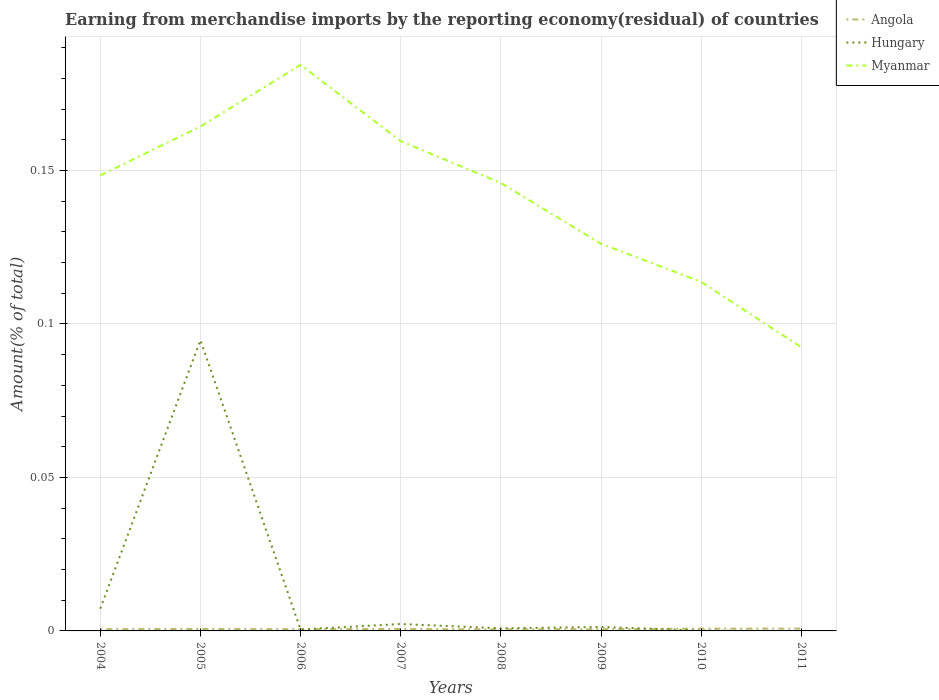Across all years, what is the maximum percentage of amount earned from merchandise imports in Myanmar?
Keep it short and to the point. 0.09. What is the total percentage of amount earned from merchandise imports in Hungary in the graph?
Offer a terse response. 0.09. What is the difference between the highest and the second highest percentage of amount earned from merchandise imports in Hungary?
Give a very brief answer. 0.09. What is the difference between two consecutive major ticks on the Y-axis?
Provide a short and direct response. 0.05. Are the values on the major ticks of Y-axis written in scientific E-notation?
Offer a very short reply. No. Does the graph contain grids?
Ensure brevity in your answer.  Yes. What is the title of the graph?
Ensure brevity in your answer.  Earning from merchandise imports by the reporting economy(residual) of countries. What is the label or title of the X-axis?
Give a very brief answer. Years. What is the label or title of the Y-axis?
Your response must be concise. Amount(% of total). What is the Amount(% of total) of Angola in 2004?
Keep it short and to the point. 0. What is the Amount(% of total) of Hungary in 2004?
Offer a very short reply. 0.01. What is the Amount(% of total) of Myanmar in 2004?
Ensure brevity in your answer.  0.15. What is the Amount(% of total) of Angola in 2005?
Make the answer very short. 0. What is the Amount(% of total) of Hungary in 2005?
Keep it short and to the point. 0.09. What is the Amount(% of total) in Myanmar in 2005?
Provide a short and direct response. 0.16. What is the Amount(% of total) of Angola in 2006?
Offer a terse response. 0. What is the Amount(% of total) in Hungary in 2006?
Provide a succinct answer. 0. What is the Amount(% of total) in Myanmar in 2006?
Your response must be concise. 0.18. What is the Amount(% of total) in Angola in 2007?
Provide a short and direct response. 0. What is the Amount(% of total) of Hungary in 2007?
Your answer should be compact. 0. What is the Amount(% of total) in Myanmar in 2007?
Keep it short and to the point. 0.16. What is the Amount(% of total) of Angola in 2008?
Your response must be concise. 0. What is the Amount(% of total) in Hungary in 2008?
Give a very brief answer. 0. What is the Amount(% of total) in Myanmar in 2008?
Give a very brief answer. 0.15. What is the Amount(% of total) in Angola in 2009?
Keep it short and to the point. 0. What is the Amount(% of total) of Hungary in 2009?
Your response must be concise. 0. What is the Amount(% of total) of Myanmar in 2009?
Keep it short and to the point. 0.13. What is the Amount(% of total) in Angola in 2010?
Provide a short and direct response. 0. What is the Amount(% of total) in Hungary in 2010?
Offer a terse response. 0. What is the Amount(% of total) in Myanmar in 2010?
Your answer should be compact. 0.11. What is the Amount(% of total) of Angola in 2011?
Make the answer very short. 0. What is the Amount(% of total) in Hungary in 2011?
Make the answer very short. 0. What is the Amount(% of total) of Myanmar in 2011?
Offer a very short reply. 0.09. Across all years, what is the maximum Amount(% of total) of Angola?
Ensure brevity in your answer.  0. Across all years, what is the maximum Amount(% of total) in Hungary?
Provide a succinct answer. 0.09. Across all years, what is the maximum Amount(% of total) of Myanmar?
Make the answer very short. 0.18. Across all years, what is the minimum Amount(% of total) of Angola?
Make the answer very short. 0. Across all years, what is the minimum Amount(% of total) of Myanmar?
Your answer should be compact. 0.09. What is the total Amount(% of total) of Angola in the graph?
Offer a very short reply. 0.01. What is the total Amount(% of total) in Hungary in the graph?
Your answer should be very brief. 0.11. What is the total Amount(% of total) in Myanmar in the graph?
Ensure brevity in your answer.  1.13. What is the difference between the Amount(% of total) in Angola in 2004 and that in 2005?
Your answer should be very brief. -0. What is the difference between the Amount(% of total) in Hungary in 2004 and that in 2005?
Your response must be concise. -0.09. What is the difference between the Amount(% of total) in Myanmar in 2004 and that in 2005?
Give a very brief answer. -0.02. What is the difference between the Amount(% of total) of Hungary in 2004 and that in 2006?
Provide a short and direct response. 0.01. What is the difference between the Amount(% of total) in Myanmar in 2004 and that in 2006?
Keep it short and to the point. -0.04. What is the difference between the Amount(% of total) of Angola in 2004 and that in 2007?
Keep it short and to the point. -0. What is the difference between the Amount(% of total) of Hungary in 2004 and that in 2007?
Your answer should be compact. 0.01. What is the difference between the Amount(% of total) in Myanmar in 2004 and that in 2007?
Offer a terse response. -0.01. What is the difference between the Amount(% of total) in Angola in 2004 and that in 2008?
Your answer should be compact. 0. What is the difference between the Amount(% of total) of Hungary in 2004 and that in 2008?
Make the answer very short. 0.01. What is the difference between the Amount(% of total) in Myanmar in 2004 and that in 2008?
Ensure brevity in your answer.  0. What is the difference between the Amount(% of total) of Hungary in 2004 and that in 2009?
Make the answer very short. 0.01. What is the difference between the Amount(% of total) in Myanmar in 2004 and that in 2009?
Provide a short and direct response. 0.02. What is the difference between the Amount(% of total) in Angola in 2004 and that in 2010?
Offer a terse response. -0. What is the difference between the Amount(% of total) of Hungary in 2004 and that in 2010?
Give a very brief answer. 0.01. What is the difference between the Amount(% of total) in Myanmar in 2004 and that in 2010?
Provide a succinct answer. 0.03. What is the difference between the Amount(% of total) of Angola in 2004 and that in 2011?
Offer a very short reply. -0. What is the difference between the Amount(% of total) in Myanmar in 2004 and that in 2011?
Give a very brief answer. 0.06. What is the difference between the Amount(% of total) of Angola in 2005 and that in 2006?
Your response must be concise. 0. What is the difference between the Amount(% of total) of Hungary in 2005 and that in 2006?
Offer a very short reply. 0.09. What is the difference between the Amount(% of total) in Myanmar in 2005 and that in 2006?
Your response must be concise. -0.02. What is the difference between the Amount(% of total) in Angola in 2005 and that in 2007?
Give a very brief answer. -0. What is the difference between the Amount(% of total) in Hungary in 2005 and that in 2007?
Provide a succinct answer. 0.09. What is the difference between the Amount(% of total) of Myanmar in 2005 and that in 2007?
Your response must be concise. 0. What is the difference between the Amount(% of total) of Hungary in 2005 and that in 2008?
Give a very brief answer. 0.09. What is the difference between the Amount(% of total) of Myanmar in 2005 and that in 2008?
Give a very brief answer. 0.02. What is the difference between the Amount(% of total) of Angola in 2005 and that in 2009?
Give a very brief answer. 0. What is the difference between the Amount(% of total) in Hungary in 2005 and that in 2009?
Keep it short and to the point. 0.09. What is the difference between the Amount(% of total) of Myanmar in 2005 and that in 2009?
Provide a succinct answer. 0.04. What is the difference between the Amount(% of total) of Angola in 2005 and that in 2010?
Ensure brevity in your answer.  -0. What is the difference between the Amount(% of total) in Hungary in 2005 and that in 2010?
Provide a short and direct response. 0.09. What is the difference between the Amount(% of total) in Myanmar in 2005 and that in 2010?
Your answer should be very brief. 0.05. What is the difference between the Amount(% of total) of Angola in 2005 and that in 2011?
Offer a very short reply. -0. What is the difference between the Amount(% of total) in Myanmar in 2005 and that in 2011?
Your answer should be compact. 0.07. What is the difference between the Amount(% of total) of Angola in 2006 and that in 2007?
Your answer should be compact. -0. What is the difference between the Amount(% of total) in Hungary in 2006 and that in 2007?
Your response must be concise. -0. What is the difference between the Amount(% of total) in Myanmar in 2006 and that in 2007?
Your answer should be compact. 0.02. What is the difference between the Amount(% of total) of Hungary in 2006 and that in 2008?
Offer a very short reply. -0. What is the difference between the Amount(% of total) of Myanmar in 2006 and that in 2008?
Your answer should be very brief. 0.04. What is the difference between the Amount(% of total) of Angola in 2006 and that in 2009?
Your answer should be very brief. 0. What is the difference between the Amount(% of total) of Hungary in 2006 and that in 2009?
Ensure brevity in your answer.  -0. What is the difference between the Amount(% of total) of Myanmar in 2006 and that in 2009?
Give a very brief answer. 0.06. What is the difference between the Amount(% of total) in Angola in 2006 and that in 2010?
Your answer should be very brief. -0. What is the difference between the Amount(% of total) in Myanmar in 2006 and that in 2010?
Provide a succinct answer. 0.07. What is the difference between the Amount(% of total) of Angola in 2006 and that in 2011?
Provide a short and direct response. -0. What is the difference between the Amount(% of total) of Myanmar in 2006 and that in 2011?
Offer a very short reply. 0.09. What is the difference between the Amount(% of total) of Angola in 2007 and that in 2008?
Your answer should be compact. 0. What is the difference between the Amount(% of total) in Hungary in 2007 and that in 2008?
Make the answer very short. 0. What is the difference between the Amount(% of total) in Myanmar in 2007 and that in 2008?
Give a very brief answer. 0.01. What is the difference between the Amount(% of total) of Hungary in 2007 and that in 2009?
Give a very brief answer. 0. What is the difference between the Amount(% of total) of Myanmar in 2007 and that in 2009?
Provide a short and direct response. 0.03. What is the difference between the Amount(% of total) in Angola in 2007 and that in 2010?
Make the answer very short. -0. What is the difference between the Amount(% of total) in Hungary in 2007 and that in 2010?
Your answer should be very brief. 0. What is the difference between the Amount(% of total) in Myanmar in 2007 and that in 2010?
Your answer should be compact. 0.05. What is the difference between the Amount(% of total) in Angola in 2007 and that in 2011?
Your response must be concise. -0. What is the difference between the Amount(% of total) in Myanmar in 2007 and that in 2011?
Your response must be concise. 0.07. What is the difference between the Amount(% of total) of Angola in 2008 and that in 2009?
Provide a succinct answer. -0. What is the difference between the Amount(% of total) in Hungary in 2008 and that in 2009?
Your answer should be compact. -0. What is the difference between the Amount(% of total) of Myanmar in 2008 and that in 2009?
Your response must be concise. 0.02. What is the difference between the Amount(% of total) in Angola in 2008 and that in 2010?
Offer a very short reply. -0. What is the difference between the Amount(% of total) in Hungary in 2008 and that in 2010?
Give a very brief answer. 0. What is the difference between the Amount(% of total) of Myanmar in 2008 and that in 2010?
Ensure brevity in your answer.  0.03. What is the difference between the Amount(% of total) of Angola in 2008 and that in 2011?
Ensure brevity in your answer.  -0. What is the difference between the Amount(% of total) of Myanmar in 2008 and that in 2011?
Ensure brevity in your answer.  0.05. What is the difference between the Amount(% of total) in Angola in 2009 and that in 2010?
Your response must be concise. -0. What is the difference between the Amount(% of total) in Hungary in 2009 and that in 2010?
Give a very brief answer. 0. What is the difference between the Amount(% of total) in Myanmar in 2009 and that in 2010?
Your answer should be very brief. 0.01. What is the difference between the Amount(% of total) of Angola in 2009 and that in 2011?
Your answer should be very brief. -0. What is the difference between the Amount(% of total) of Myanmar in 2009 and that in 2011?
Make the answer very short. 0.03. What is the difference between the Amount(% of total) of Angola in 2010 and that in 2011?
Offer a terse response. -0. What is the difference between the Amount(% of total) in Myanmar in 2010 and that in 2011?
Your answer should be very brief. 0.02. What is the difference between the Amount(% of total) of Angola in 2004 and the Amount(% of total) of Hungary in 2005?
Give a very brief answer. -0.09. What is the difference between the Amount(% of total) in Angola in 2004 and the Amount(% of total) in Myanmar in 2005?
Your response must be concise. -0.16. What is the difference between the Amount(% of total) of Hungary in 2004 and the Amount(% of total) of Myanmar in 2005?
Provide a succinct answer. -0.16. What is the difference between the Amount(% of total) of Angola in 2004 and the Amount(% of total) of Hungary in 2006?
Your answer should be very brief. 0. What is the difference between the Amount(% of total) of Angola in 2004 and the Amount(% of total) of Myanmar in 2006?
Your response must be concise. -0.18. What is the difference between the Amount(% of total) in Hungary in 2004 and the Amount(% of total) in Myanmar in 2006?
Your response must be concise. -0.18. What is the difference between the Amount(% of total) of Angola in 2004 and the Amount(% of total) of Hungary in 2007?
Keep it short and to the point. -0. What is the difference between the Amount(% of total) of Angola in 2004 and the Amount(% of total) of Myanmar in 2007?
Make the answer very short. -0.16. What is the difference between the Amount(% of total) in Hungary in 2004 and the Amount(% of total) in Myanmar in 2007?
Your response must be concise. -0.15. What is the difference between the Amount(% of total) of Angola in 2004 and the Amount(% of total) of Hungary in 2008?
Keep it short and to the point. -0. What is the difference between the Amount(% of total) in Angola in 2004 and the Amount(% of total) in Myanmar in 2008?
Provide a short and direct response. -0.15. What is the difference between the Amount(% of total) in Hungary in 2004 and the Amount(% of total) in Myanmar in 2008?
Give a very brief answer. -0.14. What is the difference between the Amount(% of total) of Angola in 2004 and the Amount(% of total) of Hungary in 2009?
Give a very brief answer. -0. What is the difference between the Amount(% of total) in Angola in 2004 and the Amount(% of total) in Myanmar in 2009?
Make the answer very short. -0.13. What is the difference between the Amount(% of total) of Hungary in 2004 and the Amount(% of total) of Myanmar in 2009?
Your answer should be compact. -0.12. What is the difference between the Amount(% of total) of Angola in 2004 and the Amount(% of total) of Hungary in 2010?
Provide a succinct answer. 0. What is the difference between the Amount(% of total) in Angola in 2004 and the Amount(% of total) in Myanmar in 2010?
Provide a succinct answer. -0.11. What is the difference between the Amount(% of total) of Hungary in 2004 and the Amount(% of total) of Myanmar in 2010?
Offer a very short reply. -0.11. What is the difference between the Amount(% of total) of Angola in 2004 and the Amount(% of total) of Myanmar in 2011?
Offer a terse response. -0.09. What is the difference between the Amount(% of total) of Hungary in 2004 and the Amount(% of total) of Myanmar in 2011?
Offer a terse response. -0.09. What is the difference between the Amount(% of total) in Angola in 2005 and the Amount(% of total) in Myanmar in 2006?
Ensure brevity in your answer.  -0.18. What is the difference between the Amount(% of total) in Hungary in 2005 and the Amount(% of total) in Myanmar in 2006?
Your answer should be very brief. -0.09. What is the difference between the Amount(% of total) in Angola in 2005 and the Amount(% of total) in Hungary in 2007?
Keep it short and to the point. -0. What is the difference between the Amount(% of total) of Angola in 2005 and the Amount(% of total) of Myanmar in 2007?
Give a very brief answer. -0.16. What is the difference between the Amount(% of total) in Hungary in 2005 and the Amount(% of total) in Myanmar in 2007?
Your response must be concise. -0.06. What is the difference between the Amount(% of total) in Angola in 2005 and the Amount(% of total) in Hungary in 2008?
Your response must be concise. -0. What is the difference between the Amount(% of total) of Angola in 2005 and the Amount(% of total) of Myanmar in 2008?
Provide a succinct answer. -0.15. What is the difference between the Amount(% of total) in Hungary in 2005 and the Amount(% of total) in Myanmar in 2008?
Provide a short and direct response. -0.05. What is the difference between the Amount(% of total) in Angola in 2005 and the Amount(% of total) in Hungary in 2009?
Provide a short and direct response. -0. What is the difference between the Amount(% of total) of Angola in 2005 and the Amount(% of total) of Myanmar in 2009?
Provide a succinct answer. -0.13. What is the difference between the Amount(% of total) of Hungary in 2005 and the Amount(% of total) of Myanmar in 2009?
Make the answer very short. -0.03. What is the difference between the Amount(% of total) in Angola in 2005 and the Amount(% of total) in Hungary in 2010?
Your answer should be compact. 0. What is the difference between the Amount(% of total) of Angola in 2005 and the Amount(% of total) of Myanmar in 2010?
Give a very brief answer. -0.11. What is the difference between the Amount(% of total) in Hungary in 2005 and the Amount(% of total) in Myanmar in 2010?
Give a very brief answer. -0.02. What is the difference between the Amount(% of total) in Angola in 2005 and the Amount(% of total) in Myanmar in 2011?
Make the answer very short. -0.09. What is the difference between the Amount(% of total) of Hungary in 2005 and the Amount(% of total) of Myanmar in 2011?
Make the answer very short. 0. What is the difference between the Amount(% of total) in Angola in 2006 and the Amount(% of total) in Hungary in 2007?
Offer a terse response. -0. What is the difference between the Amount(% of total) in Angola in 2006 and the Amount(% of total) in Myanmar in 2007?
Your answer should be compact. -0.16. What is the difference between the Amount(% of total) in Hungary in 2006 and the Amount(% of total) in Myanmar in 2007?
Your answer should be compact. -0.16. What is the difference between the Amount(% of total) in Angola in 2006 and the Amount(% of total) in Hungary in 2008?
Your response must be concise. -0. What is the difference between the Amount(% of total) of Angola in 2006 and the Amount(% of total) of Myanmar in 2008?
Your answer should be compact. -0.15. What is the difference between the Amount(% of total) of Hungary in 2006 and the Amount(% of total) of Myanmar in 2008?
Offer a very short reply. -0.15. What is the difference between the Amount(% of total) in Angola in 2006 and the Amount(% of total) in Hungary in 2009?
Your answer should be very brief. -0. What is the difference between the Amount(% of total) in Angola in 2006 and the Amount(% of total) in Myanmar in 2009?
Give a very brief answer. -0.13. What is the difference between the Amount(% of total) of Hungary in 2006 and the Amount(% of total) of Myanmar in 2009?
Your answer should be compact. -0.13. What is the difference between the Amount(% of total) of Angola in 2006 and the Amount(% of total) of Hungary in 2010?
Your answer should be compact. 0. What is the difference between the Amount(% of total) in Angola in 2006 and the Amount(% of total) in Myanmar in 2010?
Make the answer very short. -0.11. What is the difference between the Amount(% of total) of Hungary in 2006 and the Amount(% of total) of Myanmar in 2010?
Offer a very short reply. -0.11. What is the difference between the Amount(% of total) in Angola in 2006 and the Amount(% of total) in Myanmar in 2011?
Provide a short and direct response. -0.09. What is the difference between the Amount(% of total) of Hungary in 2006 and the Amount(% of total) of Myanmar in 2011?
Your answer should be very brief. -0.09. What is the difference between the Amount(% of total) of Angola in 2007 and the Amount(% of total) of Hungary in 2008?
Make the answer very short. -0. What is the difference between the Amount(% of total) of Angola in 2007 and the Amount(% of total) of Myanmar in 2008?
Offer a terse response. -0.15. What is the difference between the Amount(% of total) of Hungary in 2007 and the Amount(% of total) of Myanmar in 2008?
Your answer should be compact. -0.14. What is the difference between the Amount(% of total) in Angola in 2007 and the Amount(% of total) in Hungary in 2009?
Offer a very short reply. -0. What is the difference between the Amount(% of total) of Angola in 2007 and the Amount(% of total) of Myanmar in 2009?
Keep it short and to the point. -0.13. What is the difference between the Amount(% of total) in Hungary in 2007 and the Amount(% of total) in Myanmar in 2009?
Make the answer very short. -0.12. What is the difference between the Amount(% of total) in Angola in 2007 and the Amount(% of total) in Myanmar in 2010?
Provide a succinct answer. -0.11. What is the difference between the Amount(% of total) of Hungary in 2007 and the Amount(% of total) of Myanmar in 2010?
Your response must be concise. -0.11. What is the difference between the Amount(% of total) of Angola in 2007 and the Amount(% of total) of Myanmar in 2011?
Your answer should be very brief. -0.09. What is the difference between the Amount(% of total) in Hungary in 2007 and the Amount(% of total) in Myanmar in 2011?
Offer a terse response. -0.09. What is the difference between the Amount(% of total) in Angola in 2008 and the Amount(% of total) in Hungary in 2009?
Provide a succinct answer. -0. What is the difference between the Amount(% of total) in Angola in 2008 and the Amount(% of total) in Myanmar in 2009?
Your answer should be very brief. -0.13. What is the difference between the Amount(% of total) in Hungary in 2008 and the Amount(% of total) in Myanmar in 2009?
Make the answer very short. -0.13. What is the difference between the Amount(% of total) of Angola in 2008 and the Amount(% of total) of Myanmar in 2010?
Offer a very short reply. -0.11. What is the difference between the Amount(% of total) of Hungary in 2008 and the Amount(% of total) of Myanmar in 2010?
Give a very brief answer. -0.11. What is the difference between the Amount(% of total) in Angola in 2008 and the Amount(% of total) in Myanmar in 2011?
Your answer should be very brief. -0.09. What is the difference between the Amount(% of total) of Hungary in 2008 and the Amount(% of total) of Myanmar in 2011?
Your response must be concise. -0.09. What is the difference between the Amount(% of total) in Angola in 2009 and the Amount(% of total) in Hungary in 2010?
Your answer should be compact. 0. What is the difference between the Amount(% of total) of Angola in 2009 and the Amount(% of total) of Myanmar in 2010?
Your answer should be compact. -0.11. What is the difference between the Amount(% of total) in Hungary in 2009 and the Amount(% of total) in Myanmar in 2010?
Give a very brief answer. -0.11. What is the difference between the Amount(% of total) of Angola in 2009 and the Amount(% of total) of Myanmar in 2011?
Provide a short and direct response. -0.09. What is the difference between the Amount(% of total) in Hungary in 2009 and the Amount(% of total) in Myanmar in 2011?
Offer a very short reply. -0.09. What is the difference between the Amount(% of total) of Angola in 2010 and the Amount(% of total) of Myanmar in 2011?
Provide a succinct answer. -0.09. What is the difference between the Amount(% of total) of Hungary in 2010 and the Amount(% of total) of Myanmar in 2011?
Ensure brevity in your answer.  -0.09. What is the average Amount(% of total) of Angola per year?
Make the answer very short. 0. What is the average Amount(% of total) in Hungary per year?
Ensure brevity in your answer.  0.01. What is the average Amount(% of total) in Myanmar per year?
Offer a terse response. 0.14. In the year 2004, what is the difference between the Amount(% of total) in Angola and Amount(% of total) in Hungary?
Provide a succinct answer. -0.01. In the year 2004, what is the difference between the Amount(% of total) of Angola and Amount(% of total) of Myanmar?
Make the answer very short. -0.15. In the year 2004, what is the difference between the Amount(% of total) of Hungary and Amount(% of total) of Myanmar?
Your response must be concise. -0.14. In the year 2005, what is the difference between the Amount(% of total) in Angola and Amount(% of total) in Hungary?
Provide a short and direct response. -0.09. In the year 2005, what is the difference between the Amount(% of total) in Angola and Amount(% of total) in Myanmar?
Make the answer very short. -0.16. In the year 2005, what is the difference between the Amount(% of total) in Hungary and Amount(% of total) in Myanmar?
Make the answer very short. -0.07. In the year 2006, what is the difference between the Amount(% of total) of Angola and Amount(% of total) of Hungary?
Make the answer very short. 0. In the year 2006, what is the difference between the Amount(% of total) in Angola and Amount(% of total) in Myanmar?
Provide a succinct answer. -0.18. In the year 2006, what is the difference between the Amount(% of total) in Hungary and Amount(% of total) in Myanmar?
Offer a very short reply. -0.18. In the year 2007, what is the difference between the Amount(% of total) in Angola and Amount(% of total) in Hungary?
Offer a terse response. -0. In the year 2007, what is the difference between the Amount(% of total) of Angola and Amount(% of total) of Myanmar?
Give a very brief answer. -0.16. In the year 2007, what is the difference between the Amount(% of total) in Hungary and Amount(% of total) in Myanmar?
Offer a terse response. -0.16. In the year 2008, what is the difference between the Amount(% of total) in Angola and Amount(% of total) in Hungary?
Make the answer very short. -0. In the year 2008, what is the difference between the Amount(% of total) in Angola and Amount(% of total) in Myanmar?
Your answer should be very brief. -0.15. In the year 2008, what is the difference between the Amount(% of total) of Hungary and Amount(% of total) of Myanmar?
Provide a succinct answer. -0.15. In the year 2009, what is the difference between the Amount(% of total) in Angola and Amount(% of total) in Hungary?
Provide a short and direct response. -0. In the year 2009, what is the difference between the Amount(% of total) of Angola and Amount(% of total) of Myanmar?
Make the answer very short. -0.13. In the year 2009, what is the difference between the Amount(% of total) in Hungary and Amount(% of total) in Myanmar?
Provide a succinct answer. -0.12. In the year 2010, what is the difference between the Amount(% of total) in Angola and Amount(% of total) in Hungary?
Make the answer very short. 0. In the year 2010, what is the difference between the Amount(% of total) of Angola and Amount(% of total) of Myanmar?
Your answer should be very brief. -0.11. In the year 2010, what is the difference between the Amount(% of total) in Hungary and Amount(% of total) in Myanmar?
Your answer should be compact. -0.11. In the year 2011, what is the difference between the Amount(% of total) in Angola and Amount(% of total) in Myanmar?
Your response must be concise. -0.09. What is the ratio of the Amount(% of total) of Angola in 2004 to that in 2005?
Give a very brief answer. 0.92. What is the ratio of the Amount(% of total) in Hungary in 2004 to that in 2005?
Keep it short and to the point. 0.08. What is the ratio of the Amount(% of total) in Myanmar in 2004 to that in 2005?
Provide a succinct answer. 0.9. What is the ratio of the Amount(% of total) of Angola in 2004 to that in 2006?
Offer a terse response. 1.02. What is the ratio of the Amount(% of total) in Hungary in 2004 to that in 2006?
Your answer should be very brief. 15.88. What is the ratio of the Amount(% of total) in Myanmar in 2004 to that in 2006?
Your answer should be compact. 0.8. What is the ratio of the Amount(% of total) of Angola in 2004 to that in 2007?
Your response must be concise. 0.91. What is the ratio of the Amount(% of total) in Hungary in 2004 to that in 2007?
Offer a terse response. 3.22. What is the ratio of the Amount(% of total) of Myanmar in 2004 to that in 2007?
Ensure brevity in your answer.  0.93. What is the ratio of the Amount(% of total) in Angola in 2004 to that in 2008?
Provide a succinct answer. 1.19. What is the ratio of the Amount(% of total) of Hungary in 2004 to that in 2008?
Make the answer very short. 8.52. What is the ratio of the Amount(% of total) of Myanmar in 2004 to that in 2008?
Your answer should be compact. 1.02. What is the ratio of the Amount(% of total) in Angola in 2004 to that in 2009?
Ensure brevity in your answer.  1.03. What is the ratio of the Amount(% of total) in Hungary in 2004 to that in 2009?
Provide a succinct answer. 5.64. What is the ratio of the Amount(% of total) in Myanmar in 2004 to that in 2009?
Offer a terse response. 1.18. What is the ratio of the Amount(% of total) in Angola in 2004 to that in 2010?
Ensure brevity in your answer.  0.78. What is the ratio of the Amount(% of total) of Hungary in 2004 to that in 2010?
Provide a short and direct response. 55.19. What is the ratio of the Amount(% of total) of Myanmar in 2004 to that in 2010?
Give a very brief answer. 1.3. What is the ratio of the Amount(% of total) of Angola in 2004 to that in 2011?
Keep it short and to the point. 0.77. What is the ratio of the Amount(% of total) in Myanmar in 2004 to that in 2011?
Provide a short and direct response. 1.61. What is the ratio of the Amount(% of total) of Angola in 2005 to that in 2006?
Offer a very short reply. 1.11. What is the ratio of the Amount(% of total) of Hungary in 2005 to that in 2006?
Provide a short and direct response. 207.14. What is the ratio of the Amount(% of total) of Myanmar in 2005 to that in 2006?
Make the answer very short. 0.89. What is the ratio of the Amount(% of total) in Angola in 2005 to that in 2007?
Provide a short and direct response. 1. What is the ratio of the Amount(% of total) in Hungary in 2005 to that in 2007?
Offer a very short reply. 42.05. What is the ratio of the Amount(% of total) of Myanmar in 2005 to that in 2007?
Offer a terse response. 1.03. What is the ratio of the Amount(% of total) in Angola in 2005 to that in 2008?
Give a very brief answer. 1.29. What is the ratio of the Amount(% of total) of Hungary in 2005 to that in 2008?
Give a very brief answer. 111.08. What is the ratio of the Amount(% of total) of Myanmar in 2005 to that in 2008?
Offer a very short reply. 1.13. What is the ratio of the Amount(% of total) in Angola in 2005 to that in 2009?
Provide a short and direct response. 1.12. What is the ratio of the Amount(% of total) of Hungary in 2005 to that in 2009?
Keep it short and to the point. 73.55. What is the ratio of the Amount(% of total) in Myanmar in 2005 to that in 2009?
Make the answer very short. 1.3. What is the ratio of the Amount(% of total) in Angola in 2005 to that in 2010?
Offer a terse response. 0.85. What is the ratio of the Amount(% of total) in Hungary in 2005 to that in 2010?
Offer a terse response. 719.96. What is the ratio of the Amount(% of total) of Myanmar in 2005 to that in 2010?
Provide a short and direct response. 1.44. What is the ratio of the Amount(% of total) in Angola in 2005 to that in 2011?
Ensure brevity in your answer.  0.84. What is the ratio of the Amount(% of total) of Myanmar in 2005 to that in 2011?
Keep it short and to the point. 1.78. What is the ratio of the Amount(% of total) in Angola in 2006 to that in 2007?
Your answer should be compact. 0.9. What is the ratio of the Amount(% of total) in Hungary in 2006 to that in 2007?
Provide a succinct answer. 0.2. What is the ratio of the Amount(% of total) of Myanmar in 2006 to that in 2007?
Your response must be concise. 1.16. What is the ratio of the Amount(% of total) of Angola in 2006 to that in 2008?
Provide a short and direct response. 1.16. What is the ratio of the Amount(% of total) of Hungary in 2006 to that in 2008?
Offer a terse response. 0.54. What is the ratio of the Amount(% of total) of Myanmar in 2006 to that in 2008?
Your answer should be very brief. 1.26. What is the ratio of the Amount(% of total) in Angola in 2006 to that in 2009?
Ensure brevity in your answer.  1.01. What is the ratio of the Amount(% of total) of Hungary in 2006 to that in 2009?
Your answer should be compact. 0.36. What is the ratio of the Amount(% of total) of Myanmar in 2006 to that in 2009?
Ensure brevity in your answer.  1.46. What is the ratio of the Amount(% of total) in Angola in 2006 to that in 2010?
Keep it short and to the point. 0.76. What is the ratio of the Amount(% of total) of Hungary in 2006 to that in 2010?
Provide a short and direct response. 3.48. What is the ratio of the Amount(% of total) in Myanmar in 2006 to that in 2010?
Your response must be concise. 1.62. What is the ratio of the Amount(% of total) in Angola in 2006 to that in 2011?
Your response must be concise. 0.75. What is the ratio of the Amount(% of total) in Myanmar in 2006 to that in 2011?
Keep it short and to the point. 2. What is the ratio of the Amount(% of total) in Angola in 2007 to that in 2008?
Offer a terse response. 1.3. What is the ratio of the Amount(% of total) in Hungary in 2007 to that in 2008?
Make the answer very short. 2.64. What is the ratio of the Amount(% of total) in Myanmar in 2007 to that in 2008?
Your answer should be very brief. 1.09. What is the ratio of the Amount(% of total) in Angola in 2007 to that in 2009?
Ensure brevity in your answer.  1.13. What is the ratio of the Amount(% of total) in Hungary in 2007 to that in 2009?
Ensure brevity in your answer.  1.75. What is the ratio of the Amount(% of total) of Myanmar in 2007 to that in 2009?
Your answer should be very brief. 1.27. What is the ratio of the Amount(% of total) of Angola in 2007 to that in 2010?
Ensure brevity in your answer.  0.85. What is the ratio of the Amount(% of total) in Hungary in 2007 to that in 2010?
Provide a short and direct response. 17.12. What is the ratio of the Amount(% of total) in Myanmar in 2007 to that in 2010?
Give a very brief answer. 1.4. What is the ratio of the Amount(% of total) of Angola in 2007 to that in 2011?
Your answer should be compact. 0.84. What is the ratio of the Amount(% of total) of Myanmar in 2007 to that in 2011?
Ensure brevity in your answer.  1.73. What is the ratio of the Amount(% of total) in Angola in 2008 to that in 2009?
Ensure brevity in your answer.  0.87. What is the ratio of the Amount(% of total) of Hungary in 2008 to that in 2009?
Your answer should be compact. 0.66. What is the ratio of the Amount(% of total) in Myanmar in 2008 to that in 2009?
Offer a terse response. 1.16. What is the ratio of the Amount(% of total) in Angola in 2008 to that in 2010?
Offer a very short reply. 0.66. What is the ratio of the Amount(% of total) in Hungary in 2008 to that in 2010?
Keep it short and to the point. 6.48. What is the ratio of the Amount(% of total) of Myanmar in 2008 to that in 2010?
Your answer should be compact. 1.28. What is the ratio of the Amount(% of total) in Angola in 2008 to that in 2011?
Your answer should be compact. 0.65. What is the ratio of the Amount(% of total) of Myanmar in 2008 to that in 2011?
Give a very brief answer. 1.58. What is the ratio of the Amount(% of total) of Angola in 2009 to that in 2010?
Offer a very short reply. 0.76. What is the ratio of the Amount(% of total) of Hungary in 2009 to that in 2010?
Offer a very short reply. 9.79. What is the ratio of the Amount(% of total) in Myanmar in 2009 to that in 2010?
Make the answer very short. 1.11. What is the ratio of the Amount(% of total) of Angola in 2009 to that in 2011?
Your response must be concise. 0.75. What is the ratio of the Amount(% of total) of Myanmar in 2009 to that in 2011?
Provide a short and direct response. 1.36. What is the ratio of the Amount(% of total) of Myanmar in 2010 to that in 2011?
Offer a terse response. 1.23. What is the difference between the highest and the second highest Amount(% of total) in Hungary?
Your answer should be very brief. 0.09. What is the difference between the highest and the second highest Amount(% of total) of Myanmar?
Give a very brief answer. 0.02. What is the difference between the highest and the lowest Amount(% of total) in Angola?
Offer a very short reply. 0. What is the difference between the highest and the lowest Amount(% of total) in Hungary?
Give a very brief answer. 0.09. What is the difference between the highest and the lowest Amount(% of total) in Myanmar?
Offer a very short reply. 0.09. 